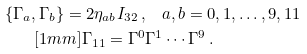<formula> <loc_0><loc_0><loc_500><loc_500>\{ \Gamma _ { a } , \Gamma _ { b } \} = 2 \eta _ { a b } I _ { 3 2 } \, , & \quad a , b = 0 , 1 , \dots , 9 , 1 1 \\ [ 1 m m ] \Gamma _ { 1 1 } = \Gamma ^ { 0 } & \Gamma ^ { 1 } \cdots \Gamma ^ { 9 } \, .</formula> 